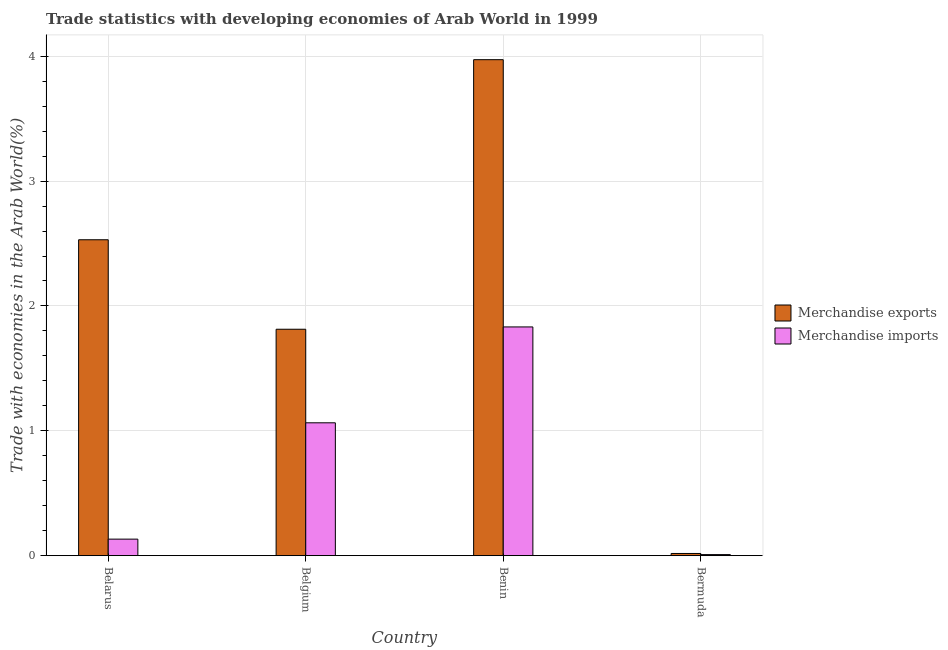How many different coloured bars are there?
Your answer should be very brief. 2. How many groups of bars are there?
Provide a short and direct response. 4. Are the number of bars on each tick of the X-axis equal?
Your answer should be very brief. Yes. How many bars are there on the 2nd tick from the left?
Your response must be concise. 2. What is the label of the 4th group of bars from the left?
Provide a succinct answer. Bermuda. In how many cases, is the number of bars for a given country not equal to the number of legend labels?
Your response must be concise. 0. What is the merchandise imports in Benin?
Ensure brevity in your answer.  1.83. Across all countries, what is the maximum merchandise exports?
Your response must be concise. 3.97. Across all countries, what is the minimum merchandise imports?
Provide a succinct answer. 0.01. In which country was the merchandise imports maximum?
Offer a very short reply. Benin. In which country was the merchandise exports minimum?
Your answer should be compact. Bermuda. What is the total merchandise exports in the graph?
Provide a short and direct response. 8.33. What is the difference between the merchandise exports in Belarus and that in Benin?
Ensure brevity in your answer.  -1.44. What is the difference between the merchandise imports in Benin and the merchandise exports in Belgium?
Make the answer very short. 0.02. What is the average merchandise imports per country?
Keep it short and to the point. 0.76. What is the difference between the merchandise exports and merchandise imports in Bermuda?
Offer a very short reply. 0.01. What is the ratio of the merchandise imports in Belgium to that in Bermuda?
Give a very brief answer. 126.49. What is the difference between the highest and the second highest merchandise imports?
Ensure brevity in your answer.  0.77. What is the difference between the highest and the lowest merchandise exports?
Ensure brevity in your answer.  3.95. In how many countries, is the merchandise exports greater than the average merchandise exports taken over all countries?
Ensure brevity in your answer.  2. Is the sum of the merchandise imports in Belgium and Benin greater than the maximum merchandise exports across all countries?
Your answer should be compact. No. What does the 2nd bar from the left in Belarus represents?
Provide a short and direct response. Merchandise imports. What does the 2nd bar from the right in Belarus represents?
Keep it short and to the point. Merchandise exports. How many countries are there in the graph?
Keep it short and to the point. 4. Does the graph contain any zero values?
Your answer should be very brief. No. Does the graph contain grids?
Your response must be concise. Yes. How many legend labels are there?
Provide a succinct answer. 2. How are the legend labels stacked?
Provide a succinct answer. Vertical. What is the title of the graph?
Offer a terse response. Trade statistics with developing economies of Arab World in 1999. Does "Under-5(male)" appear as one of the legend labels in the graph?
Offer a very short reply. No. What is the label or title of the X-axis?
Your answer should be very brief. Country. What is the label or title of the Y-axis?
Offer a very short reply. Trade with economies in the Arab World(%). What is the Trade with economies in the Arab World(%) in Merchandise exports in Belarus?
Your answer should be very brief. 2.53. What is the Trade with economies in the Arab World(%) of Merchandise imports in Belarus?
Your answer should be very brief. 0.13. What is the Trade with economies in the Arab World(%) of Merchandise exports in Belgium?
Offer a very short reply. 1.81. What is the Trade with economies in the Arab World(%) of Merchandise imports in Belgium?
Offer a terse response. 1.06. What is the Trade with economies in the Arab World(%) of Merchandise exports in Benin?
Your response must be concise. 3.97. What is the Trade with economies in the Arab World(%) of Merchandise imports in Benin?
Make the answer very short. 1.83. What is the Trade with economies in the Arab World(%) in Merchandise exports in Bermuda?
Your answer should be compact. 0.02. What is the Trade with economies in the Arab World(%) of Merchandise imports in Bermuda?
Keep it short and to the point. 0.01. Across all countries, what is the maximum Trade with economies in the Arab World(%) in Merchandise exports?
Provide a short and direct response. 3.97. Across all countries, what is the maximum Trade with economies in the Arab World(%) in Merchandise imports?
Provide a short and direct response. 1.83. Across all countries, what is the minimum Trade with economies in the Arab World(%) in Merchandise exports?
Your response must be concise. 0.02. Across all countries, what is the minimum Trade with economies in the Arab World(%) in Merchandise imports?
Your response must be concise. 0.01. What is the total Trade with economies in the Arab World(%) of Merchandise exports in the graph?
Offer a very short reply. 8.33. What is the total Trade with economies in the Arab World(%) of Merchandise imports in the graph?
Provide a succinct answer. 3.04. What is the difference between the Trade with economies in the Arab World(%) in Merchandise exports in Belarus and that in Belgium?
Your response must be concise. 0.72. What is the difference between the Trade with economies in the Arab World(%) of Merchandise imports in Belarus and that in Belgium?
Your response must be concise. -0.93. What is the difference between the Trade with economies in the Arab World(%) in Merchandise exports in Belarus and that in Benin?
Give a very brief answer. -1.44. What is the difference between the Trade with economies in the Arab World(%) of Merchandise imports in Belarus and that in Benin?
Offer a terse response. -1.7. What is the difference between the Trade with economies in the Arab World(%) in Merchandise exports in Belarus and that in Bermuda?
Offer a very short reply. 2.51. What is the difference between the Trade with economies in the Arab World(%) of Merchandise imports in Belarus and that in Bermuda?
Your response must be concise. 0.12. What is the difference between the Trade with economies in the Arab World(%) of Merchandise exports in Belgium and that in Benin?
Offer a terse response. -2.16. What is the difference between the Trade with economies in the Arab World(%) in Merchandise imports in Belgium and that in Benin?
Your answer should be compact. -0.77. What is the difference between the Trade with economies in the Arab World(%) in Merchandise exports in Belgium and that in Bermuda?
Give a very brief answer. 1.8. What is the difference between the Trade with economies in the Arab World(%) of Merchandise imports in Belgium and that in Bermuda?
Your answer should be compact. 1.06. What is the difference between the Trade with economies in the Arab World(%) in Merchandise exports in Benin and that in Bermuda?
Your answer should be very brief. 3.96. What is the difference between the Trade with economies in the Arab World(%) of Merchandise imports in Benin and that in Bermuda?
Give a very brief answer. 1.82. What is the difference between the Trade with economies in the Arab World(%) in Merchandise exports in Belarus and the Trade with economies in the Arab World(%) in Merchandise imports in Belgium?
Make the answer very short. 1.47. What is the difference between the Trade with economies in the Arab World(%) in Merchandise exports in Belarus and the Trade with economies in the Arab World(%) in Merchandise imports in Benin?
Your response must be concise. 0.7. What is the difference between the Trade with economies in the Arab World(%) of Merchandise exports in Belarus and the Trade with economies in the Arab World(%) of Merchandise imports in Bermuda?
Keep it short and to the point. 2.52. What is the difference between the Trade with economies in the Arab World(%) of Merchandise exports in Belgium and the Trade with economies in the Arab World(%) of Merchandise imports in Benin?
Give a very brief answer. -0.02. What is the difference between the Trade with economies in the Arab World(%) of Merchandise exports in Belgium and the Trade with economies in the Arab World(%) of Merchandise imports in Bermuda?
Ensure brevity in your answer.  1.8. What is the difference between the Trade with economies in the Arab World(%) of Merchandise exports in Benin and the Trade with economies in the Arab World(%) of Merchandise imports in Bermuda?
Your answer should be very brief. 3.96. What is the average Trade with economies in the Arab World(%) of Merchandise exports per country?
Your answer should be very brief. 2.08. What is the average Trade with economies in the Arab World(%) of Merchandise imports per country?
Your response must be concise. 0.76. What is the difference between the Trade with economies in the Arab World(%) of Merchandise exports and Trade with economies in the Arab World(%) of Merchandise imports in Belarus?
Provide a short and direct response. 2.4. What is the difference between the Trade with economies in the Arab World(%) of Merchandise exports and Trade with economies in the Arab World(%) of Merchandise imports in Belgium?
Your response must be concise. 0.75. What is the difference between the Trade with economies in the Arab World(%) in Merchandise exports and Trade with economies in the Arab World(%) in Merchandise imports in Benin?
Provide a short and direct response. 2.14. What is the difference between the Trade with economies in the Arab World(%) in Merchandise exports and Trade with economies in the Arab World(%) in Merchandise imports in Bermuda?
Offer a terse response. 0.01. What is the ratio of the Trade with economies in the Arab World(%) of Merchandise exports in Belarus to that in Belgium?
Your answer should be very brief. 1.4. What is the ratio of the Trade with economies in the Arab World(%) of Merchandise imports in Belarus to that in Belgium?
Your answer should be very brief. 0.12. What is the ratio of the Trade with economies in the Arab World(%) in Merchandise exports in Belarus to that in Benin?
Keep it short and to the point. 0.64. What is the ratio of the Trade with economies in the Arab World(%) of Merchandise imports in Belarus to that in Benin?
Keep it short and to the point. 0.07. What is the ratio of the Trade with economies in the Arab World(%) of Merchandise exports in Belarus to that in Bermuda?
Make the answer very short. 144.83. What is the ratio of the Trade with economies in the Arab World(%) in Merchandise imports in Belarus to that in Bermuda?
Your answer should be very brief. 15.73. What is the ratio of the Trade with economies in the Arab World(%) of Merchandise exports in Belgium to that in Benin?
Keep it short and to the point. 0.46. What is the ratio of the Trade with economies in the Arab World(%) of Merchandise imports in Belgium to that in Benin?
Offer a very short reply. 0.58. What is the ratio of the Trade with economies in the Arab World(%) of Merchandise exports in Belgium to that in Bermuda?
Your answer should be very brief. 103.81. What is the ratio of the Trade with economies in the Arab World(%) in Merchandise imports in Belgium to that in Bermuda?
Keep it short and to the point. 126.49. What is the ratio of the Trade with economies in the Arab World(%) of Merchandise exports in Benin to that in Bermuda?
Provide a short and direct response. 227.4. What is the ratio of the Trade with economies in the Arab World(%) in Merchandise imports in Benin to that in Bermuda?
Make the answer very short. 217.77. What is the difference between the highest and the second highest Trade with economies in the Arab World(%) in Merchandise exports?
Provide a short and direct response. 1.44. What is the difference between the highest and the second highest Trade with economies in the Arab World(%) of Merchandise imports?
Offer a very short reply. 0.77. What is the difference between the highest and the lowest Trade with economies in the Arab World(%) of Merchandise exports?
Make the answer very short. 3.96. What is the difference between the highest and the lowest Trade with economies in the Arab World(%) of Merchandise imports?
Offer a terse response. 1.82. 